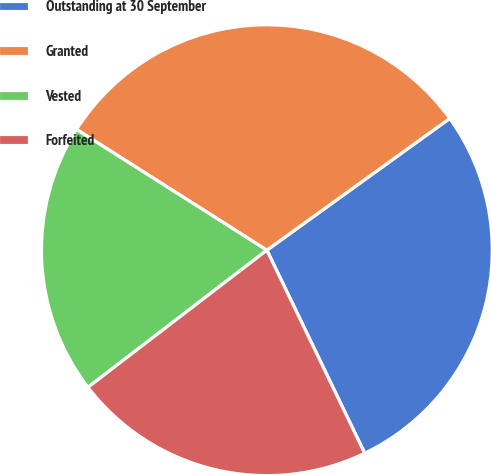Convert chart. <chart><loc_0><loc_0><loc_500><loc_500><pie_chart><fcel>Outstanding at 30 September<fcel>Granted<fcel>Vested<fcel>Forfeited<nl><fcel>27.79%<fcel>31.06%<fcel>19.41%<fcel>21.74%<nl></chart> 